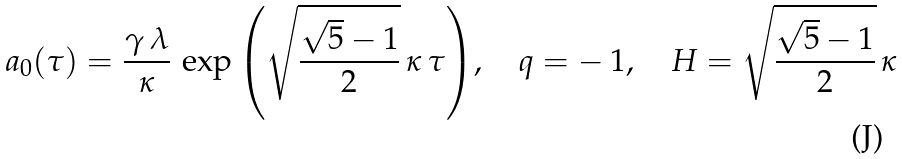<formula> <loc_0><loc_0><loc_500><loc_500>a _ { 0 } ( \tau ) = \frac { \gamma \, \lambda } { \kappa } \, \exp { \left ( \sqrt { \frac { \sqrt { 5 } - 1 } { 2 } } \, \kappa \, \tau \right ) } , \quad q = - \, 1 , \quad H = \sqrt { \frac { \sqrt { 5 } - 1 } { 2 } } \, \kappa</formula> 